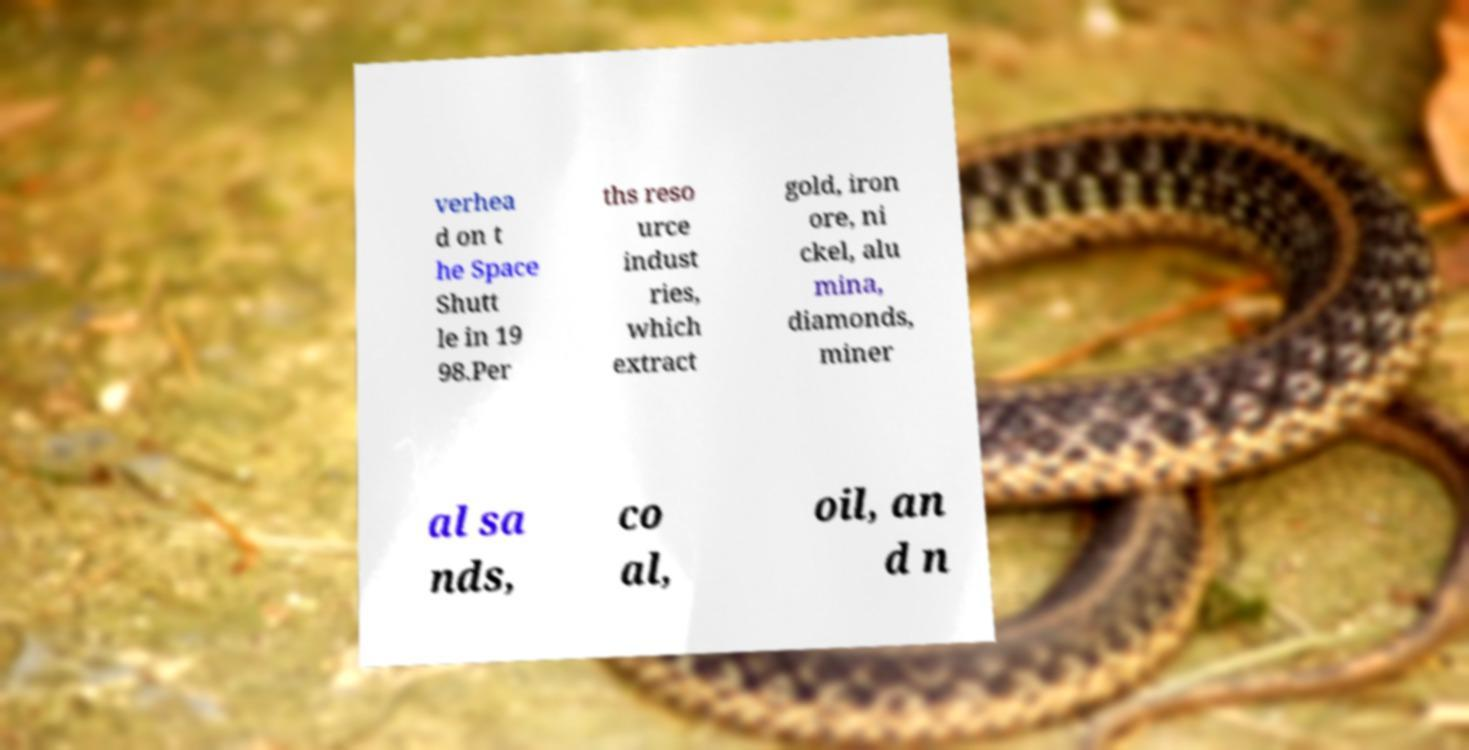There's text embedded in this image that I need extracted. Can you transcribe it verbatim? verhea d on t he Space Shutt le in 19 98.Per ths reso urce indust ries, which extract gold, iron ore, ni ckel, alu mina, diamonds, miner al sa nds, co al, oil, an d n 